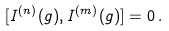Convert formula to latex. <formula><loc_0><loc_0><loc_500><loc_500>[ I ^ { ( n ) } ( g ) , I ^ { ( m ) } ( g ) ] = 0 \, .</formula> 